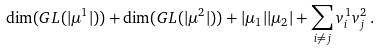Convert formula to latex. <formula><loc_0><loc_0><loc_500><loc_500>\dim ( G L ( | \mu ^ { 1 } | ) ) + \dim ( G L ( | \mu ^ { 2 } | ) ) + | \mu _ { 1 } | | \mu _ { 2 } | + \sum _ { i \neq j } v ^ { 1 } _ { i } v ^ { 2 } _ { j } \, .</formula> 